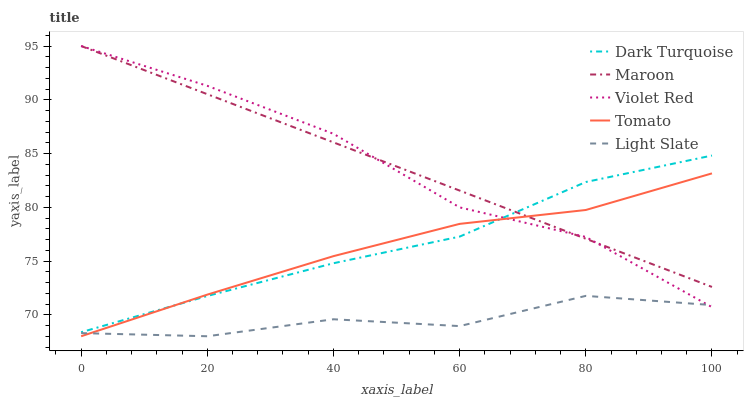Does Light Slate have the minimum area under the curve?
Answer yes or no. Yes. Does Maroon have the maximum area under the curve?
Answer yes or no. Yes. Does Dark Turquoise have the minimum area under the curve?
Answer yes or no. No. Does Dark Turquoise have the maximum area under the curve?
Answer yes or no. No. Is Maroon the smoothest?
Answer yes or no. Yes. Is Light Slate the roughest?
Answer yes or no. Yes. Is Dark Turquoise the smoothest?
Answer yes or no. No. Is Dark Turquoise the roughest?
Answer yes or no. No. Does Dark Turquoise have the lowest value?
Answer yes or no. No. Does Maroon have the highest value?
Answer yes or no. Yes. Does Dark Turquoise have the highest value?
Answer yes or no. No. Is Light Slate less than Dark Turquoise?
Answer yes or no. Yes. Is Maroon greater than Light Slate?
Answer yes or no. Yes. Does Violet Red intersect Light Slate?
Answer yes or no. Yes. Is Violet Red less than Light Slate?
Answer yes or no. No. Is Violet Red greater than Light Slate?
Answer yes or no. No. Does Light Slate intersect Dark Turquoise?
Answer yes or no. No. 